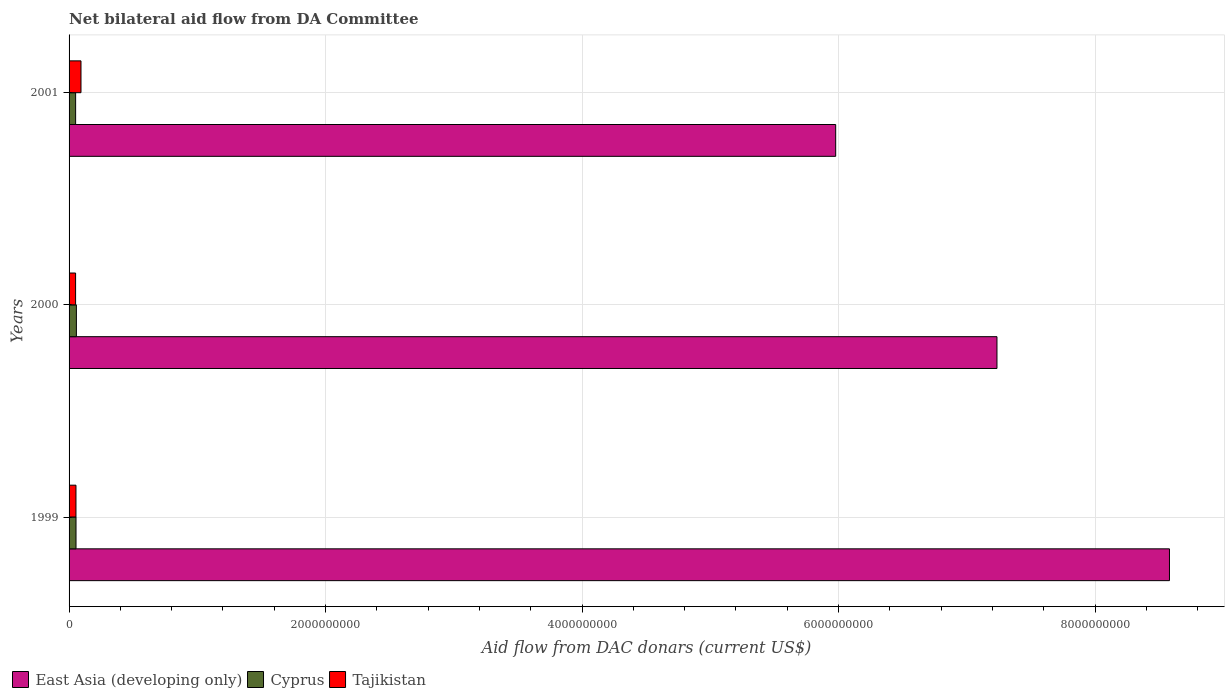What is the label of the 2nd group of bars from the top?
Your answer should be very brief. 2000. What is the aid flow in in Tajikistan in 2000?
Provide a succinct answer. 5.08e+07. Across all years, what is the maximum aid flow in in Cyprus?
Provide a succinct answer. 5.70e+07. Across all years, what is the minimum aid flow in in East Asia (developing only)?
Keep it short and to the point. 5.98e+09. In which year was the aid flow in in East Asia (developing only) maximum?
Your answer should be compact. 1999. In which year was the aid flow in in Cyprus minimum?
Give a very brief answer. 2001. What is the total aid flow in in Tajikistan in the graph?
Provide a short and direct response. 1.98e+08. What is the difference between the aid flow in in Tajikistan in 2001 and the aid flow in in Cyprus in 1999?
Offer a terse response. 3.88e+07. What is the average aid flow in in Cyprus per year?
Make the answer very short. 5.41e+07. In the year 2001, what is the difference between the aid flow in in Cyprus and aid flow in in Tajikistan?
Give a very brief answer. -4.18e+07. What is the ratio of the aid flow in in East Asia (developing only) in 1999 to that in 2001?
Ensure brevity in your answer.  1.44. What is the difference between the highest and the second highest aid flow in in Tajikistan?
Keep it short and to the point. 3.91e+07. What is the difference between the highest and the lowest aid flow in in East Asia (developing only)?
Your response must be concise. 2.60e+09. In how many years, is the aid flow in in Cyprus greater than the average aid flow in in Cyprus taken over all years?
Your answer should be very brief. 2. What does the 3rd bar from the top in 1999 represents?
Your answer should be very brief. East Asia (developing only). What does the 1st bar from the bottom in 2000 represents?
Your answer should be compact. East Asia (developing only). How many years are there in the graph?
Provide a succinct answer. 3. What is the difference between two consecutive major ticks on the X-axis?
Offer a very short reply. 2.00e+09. Are the values on the major ticks of X-axis written in scientific E-notation?
Your answer should be very brief. No. Does the graph contain grids?
Offer a terse response. Yes. Where does the legend appear in the graph?
Make the answer very short. Bottom left. What is the title of the graph?
Offer a terse response. Net bilateral aid flow from DA Committee. Does "Isle of Man" appear as one of the legend labels in the graph?
Provide a succinct answer. No. What is the label or title of the X-axis?
Provide a short and direct response. Aid flow from DAC donars (current US$). What is the label or title of the Y-axis?
Ensure brevity in your answer.  Years. What is the Aid flow from DAC donars (current US$) in East Asia (developing only) in 1999?
Your response must be concise. 8.58e+09. What is the Aid flow from DAC donars (current US$) in Cyprus in 1999?
Provide a short and direct response. 5.41e+07. What is the Aid flow from DAC donars (current US$) in Tajikistan in 1999?
Your answer should be compact. 5.38e+07. What is the Aid flow from DAC donars (current US$) in East Asia (developing only) in 2000?
Offer a terse response. 7.24e+09. What is the Aid flow from DAC donars (current US$) of Cyprus in 2000?
Give a very brief answer. 5.70e+07. What is the Aid flow from DAC donars (current US$) in Tajikistan in 2000?
Offer a terse response. 5.08e+07. What is the Aid flow from DAC donars (current US$) of East Asia (developing only) in 2001?
Keep it short and to the point. 5.98e+09. What is the Aid flow from DAC donars (current US$) in Cyprus in 2001?
Make the answer very short. 5.11e+07. What is the Aid flow from DAC donars (current US$) of Tajikistan in 2001?
Your answer should be very brief. 9.29e+07. Across all years, what is the maximum Aid flow from DAC donars (current US$) of East Asia (developing only)?
Give a very brief answer. 8.58e+09. Across all years, what is the maximum Aid flow from DAC donars (current US$) in Cyprus?
Make the answer very short. 5.70e+07. Across all years, what is the maximum Aid flow from DAC donars (current US$) of Tajikistan?
Your response must be concise. 9.29e+07. Across all years, what is the minimum Aid flow from DAC donars (current US$) of East Asia (developing only)?
Provide a succinct answer. 5.98e+09. Across all years, what is the minimum Aid flow from DAC donars (current US$) of Cyprus?
Ensure brevity in your answer.  5.11e+07. Across all years, what is the minimum Aid flow from DAC donars (current US$) in Tajikistan?
Offer a terse response. 5.08e+07. What is the total Aid flow from DAC donars (current US$) in East Asia (developing only) in the graph?
Your answer should be compact. 2.18e+1. What is the total Aid flow from DAC donars (current US$) in Cyprus in the graph?
Make the answer very short. 1.62e+08. What is the total Aid flow from DAC donars (current US$) in Tajikistan in the graph?
Give a very brief answer. 1.98e+08. What is the difference between the Aid flow from DAC donars (current US$) in East Asia (developing only) in 1999 and that in 2000?
Your response must be concise. 1.35e+09. What is the difference between the Aid flow from DAC donars (current US$) in Cyprus in 1999 and that in 2000?
Offer a terse response. -2.93e+06. What is the difference between the Aid flow from DAC donars (current US$) of East Asia (developing only) in 1999 and that in 2001?
Offer a very short reply. 2.60e+09. What is the difference between the Aid flow from DAC donars (current US$) of Cyprus in 1999 and that in 2001?
Make the answer very short. 3.00e+06. What is the difference between the Aid flow from DAC donars (current US$) of Tajikistan in 1999 and that in 2001?
Your answer should be compact. -3.91e+07. What is the difference between the Aid flow from DAC donars (current US$) of East Asia (developing only) in 2000 and that in 2001?
Your answer should be very brief. 1.26e+09. What is the difference between the Aid flow from DAC donars (current US$) in Cyprus in 2000 and that in 2001?
Offer a terse response. 5.93e+06. What is the difference between the Aid flow from DAC donars (current US$) in Tajikistan in 2000 and that in 2001?
Provide a succinct answer. -4.21e+07. What is the difference between the Aid flow from DAC donars (current US$) in East Asia (developing only) in 1999 and the Aid flow from DAC donars (current US$) in Cyprus in 2000?
Ensure brevity in your answer.  8.52e+09. What is the difference between the Aid flow from DAC donars (current US$) in East Asia (developing only) in 1999 and the Aid flow from DAC donars (current US$) in Tajikistan in 2000?
Your answer should be very brief. 8.53e+09. What is the difference between the Aid flow from DAC donars (current US$) in Cyprus in 1999 and the Aid flow from DAC donars (current US$) in Tajikistan in 2000?
Provide a succinct answer. 3.31e+06. What is the difference between the Aid flow from DAC donars (current US$) in East Asia (developing only) in 1999 and the Aid flow from DAC donars (current US$) in Cyprus in 2001?
Your answer should be very brief. 8.53e+09. What is the difference between the Aid flow from DAC donars (current US$) of East Asia (developing only) in 1999 and the Aid flow from DAC donars (current US$) of Tajikistan in 2001?
Offer a very short reply. 8.49e+09. What is the difference between the Aid flow from DAC donars (current US$) of Cyprus in 1999 and the Aid flow from DAC donars (current US$) of Tajikistan in 2001?
Offer a very short reply. -3.88e+07. What is the difference between the Aid flow from DAC donars (current US$) of East Asia (developing only) in 2000 and the Aid flow from DAC donars (current US$) of Cyprus in 2001?
Your answer should be very brief. 7.18e+09. What is the difference between the Aid flow from DAC donars (current US$) in East Asia (developing only) in 2000 and the Aid flow from DAC donars (current US$) in Tajikistan in 2001?
Make the answer very short. 7.14e+09. What is the difference between the Aid flow from DAC donars (current US$) of Cyprus in 2000 and the Aid flow from DAC donars (current US$) of Tajikistan in 2001?
Provide a succinct answer. -3.59e+07. What is the average Aid flow from DAC donars (current US$) of East Asia (developing only) per year?
Make the answer very short. 7.26e+09. What is the average Aid flow from DAC donars (current US$) in Cyprus per year?
Your answer should be very brief. 5.41e+07. What is the average Aid flow from DAC donars (current US$) of Tajikistan per year?
Make the answer very short. 6.58e+07. In the year 1999, what is the difference between the Aid flow from DAC donars (current US$) in East Asia (developing only) and Aid flow from DAC donars (current US$) in Cyprus?
Keep it short and to the point. 8.53e+09. In the year 1999, what is the difference between the Aid flow from DAC donars (current US$) in East Asia (developing only) and Aid flow from DAC donars (current US$) in Tajikistan?
Your answer should be compact. 8.53e+09. In the year 1999, what is the difference between the Aid flow from DAC donars (current US$) in Cyprus and Aid flow from DAC donars (current US$) in Tajikistan?
Provide a short and direct response. 3.10e+05. In the year 2000, what is the difference between the Aid flow from DAC donars (current US$) of East Asia (developing only) and Aid flow from DAC donars (current US$) of Cyprus?
Make the answer very short. 7.18e+09. In the year 2000, what is the difference between the Aid flow from DAC donars (current US$) of East Asia (developing only) and Aid flow from DAC donars (current US$) of Tajikistan?
Ensure brevity in your answer.  7.18e+09. In the year 2000, what is the difference between the Aid flow from DAC donars (current US$) of Cyprus and Aid flow from DAC donars (current US$) of Tajikistan?
Your response must be concise. 6.24e+06. In the year 2001, what is the difference between the Aid flow from DAC donars (current US$) in East Asia (developing only) and Aid flow from DAC donars (current US$) in Cyprus?
Keep it short and to the point. 5.93e+09. In the year 2001, what is the difference between the Aid flow from DAC donars (current US$) in East Asia (developing only) and Aid flow from DAC donars (current US$) in Tajikistan?
Provide a succinct answer. 5.88e+09. In the year 2001, what is the difference between the Aid flow from DAC donars (current US$) in Cyprus and Aid flow from DAC donars (current US$) in Tajikistan?
Your answer should be very brief. -4.18e+07. What is the ratio of the Aid flow from DAC donars (current US$) of East Asia (developing only) in 1999 to that in 2000?
Ensure brevity in your answer.  1.19. What is the ratio of the Aid flow from DAC donars (current US$) of Cyprus in 1999 to that in 2000?
Offer a terse response. 0.95. What is the ratio of the Aid flow from DAC donars (current US$) in Tajikistan in 1999 to that in 2000?
Offer a very short reply. 1.06. What is the ratio of the Aid flow from DAC donars (current US$) of East Asia (developing only) in 1999 to that in 2001?
Your response must be concise. 1.44. What is the ratio of the Aid flow from DAC donars (current US$) in Cyprus in 1999 to that in 2001?
Provide a short and direct response. 1.06. What is the ratio of the Aid flow from DAC donars (current US$) of Tajikistan in 1999 to that in 2001?
Offer a terse response. 0.58. What is the ratio of the Aid flow from DAC donars (current US$) of East Asia (developing only) in 2000 to that in 2001?
Give a very brief answer. 1.21. What is the ratio of the Aid flow from DAC donars (current US$) of Cyprus in 2000 to that in 2001?
Offer a terse response. 1.12. What is the ratio of the Aid flow from DAC donars (current US$) of Tajikistan in 2000 to that in 2001?
Make the answer very short. 0.55. What is the difference between the highest and the second highest Aid flow from DAC donars (current US$) of East Asia (developing only)?
Keep it short and to the point. 1.35e+09. What is the difference between the highest and the second highest Aid flow from DAC donars (current US$) in Cyprus?
Give a very brief answer. 2.93e+06. What is the difference between the highest and the second highest Aid flow from DAC donars (current US$) of Tajikistan?
Your response must be concise. 3.91e+07. What is the difference between the highest and the lowest Aid flow from DAC donars (current US$) of East Asia (developing only)?
Keep it short and to the point. 2.60e+09. What is the difference between the highest and the lowest Aid flow from DAC donars (current US$) of Cyprus?
Your answer should be very brief. 5.93e+06. What is the difference between the highest and the lowest Aid flow from DAC donars (current US$) of Tajikistan?
Offer a terse response. 4.21e+07. 